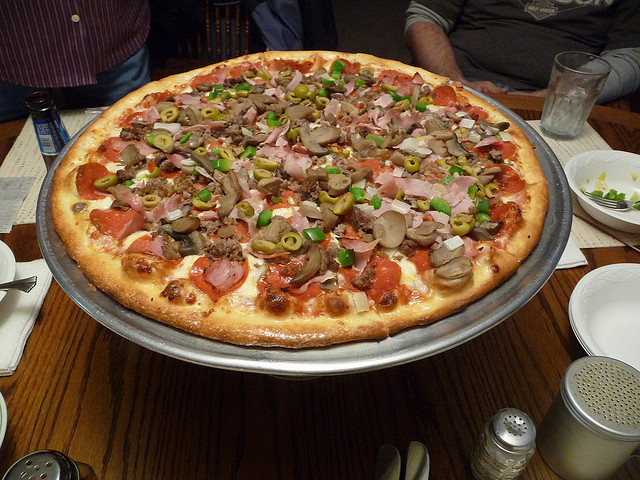How many people are in the photo? The image doesn't contain any people, but it showcases a deliciously topped large pizza, ready to be enjoyed. It seems to be placed on a table suggesting it was just served. 